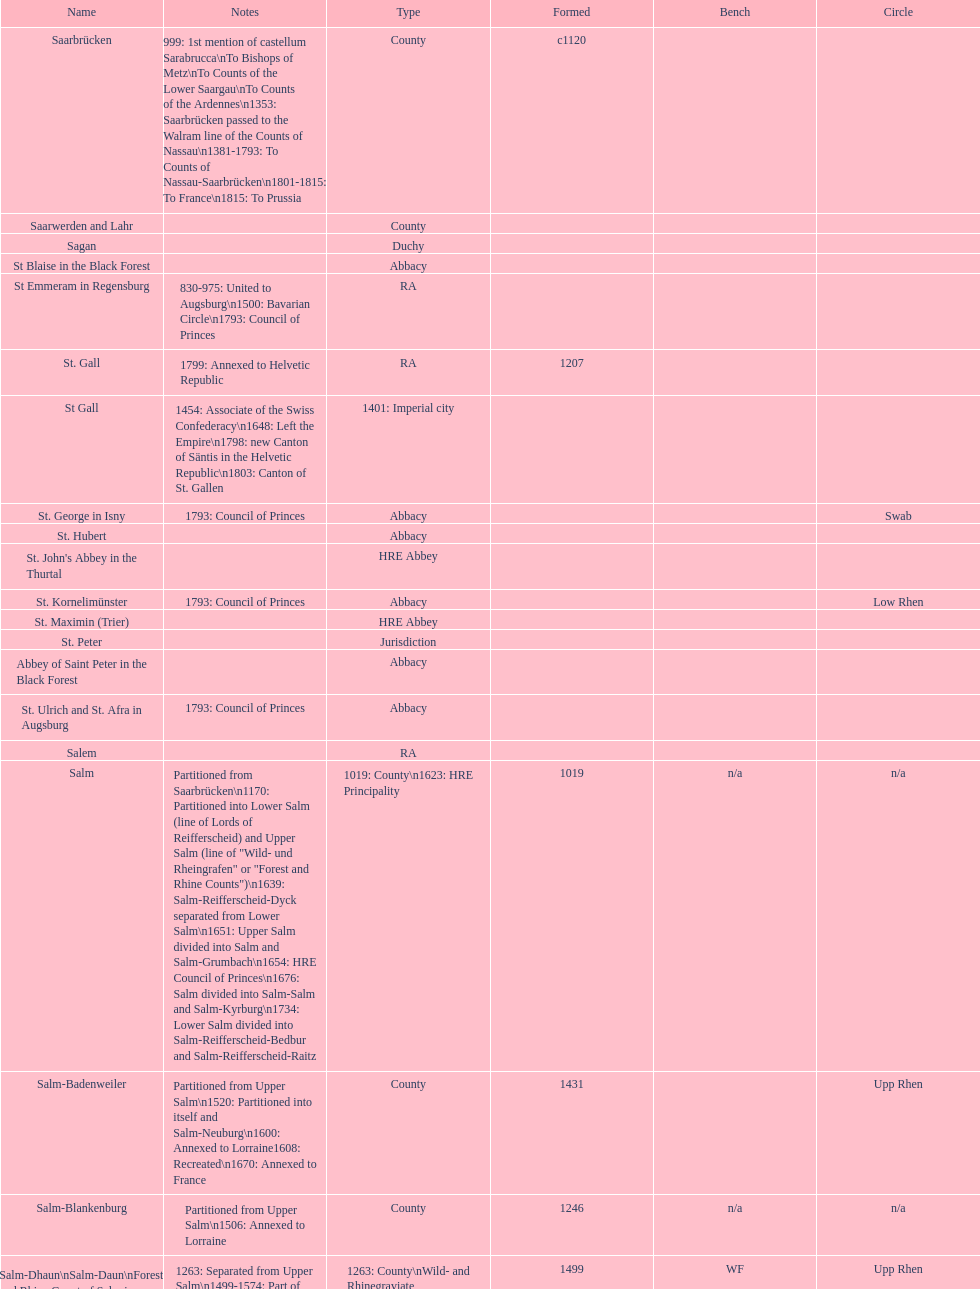How many states were of the same type as stuhlingen? 3. 